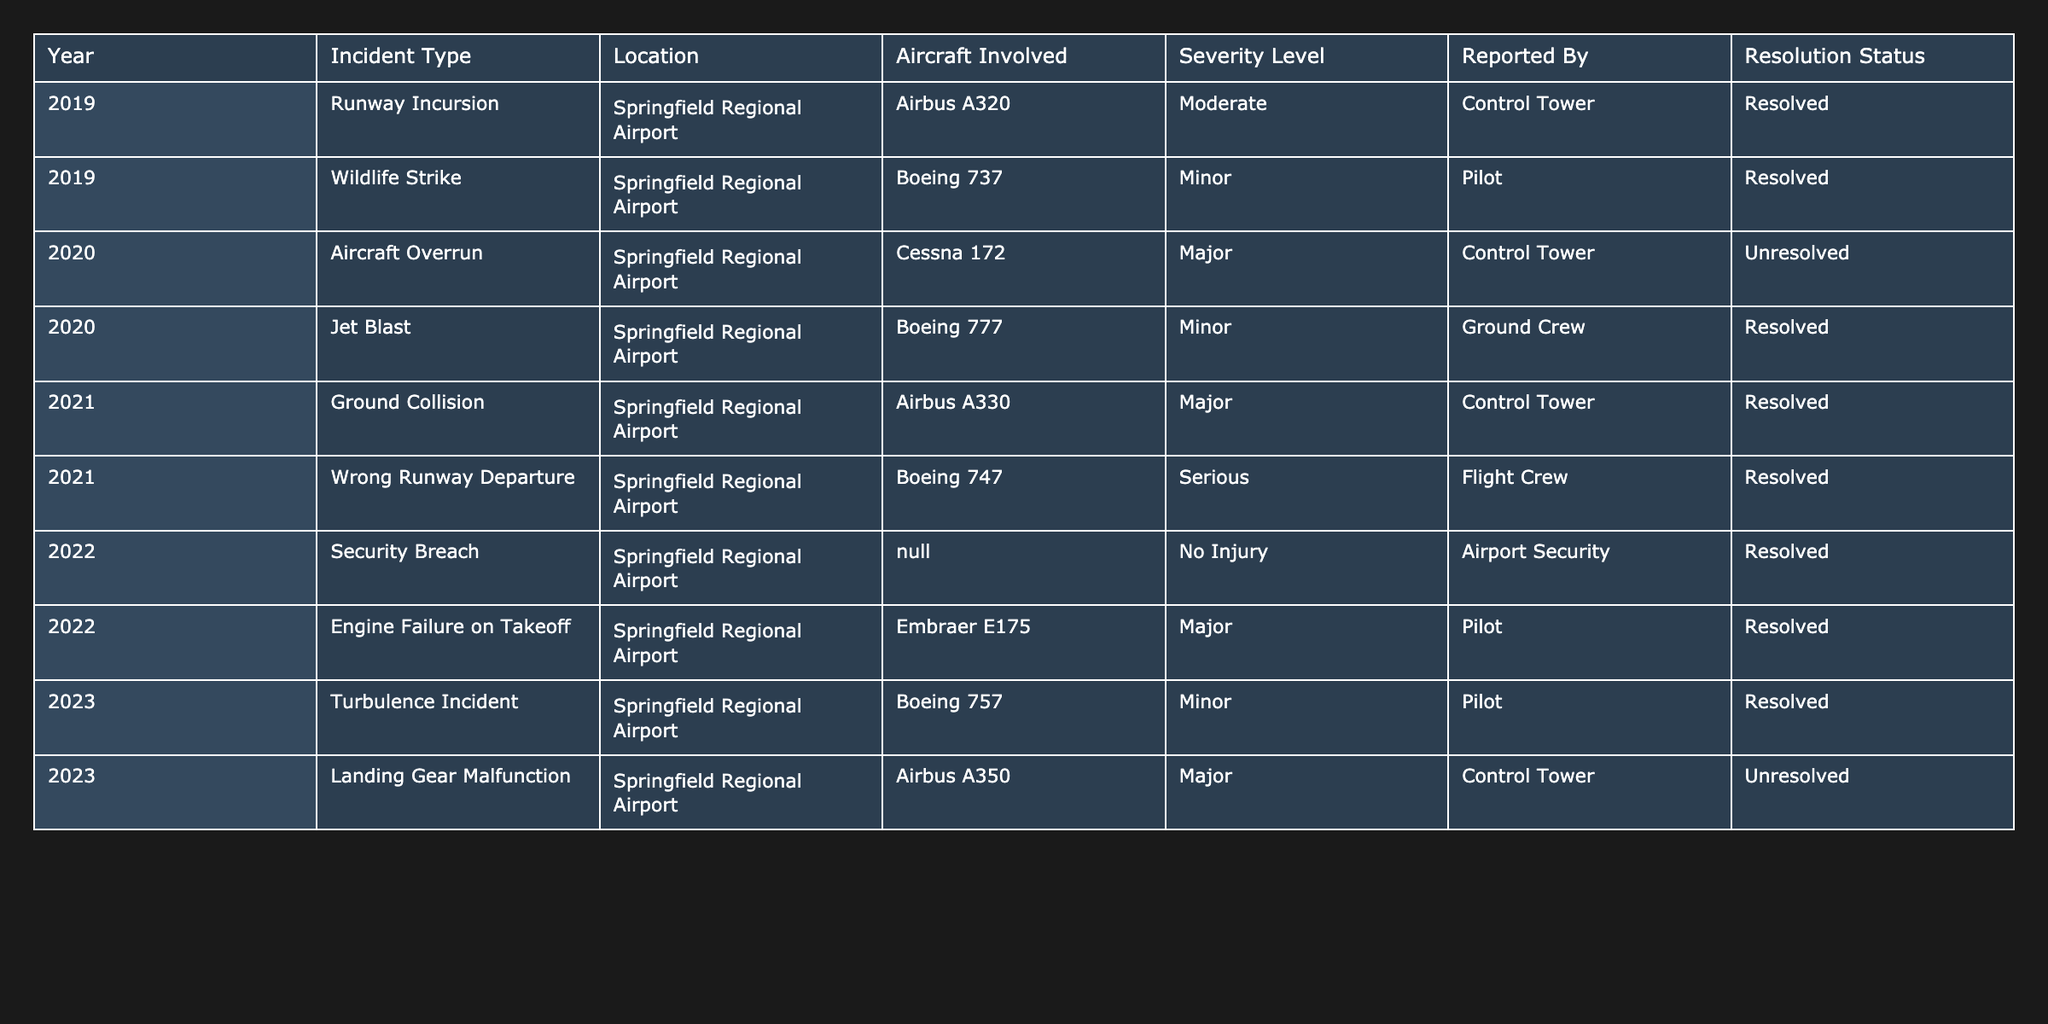What was the most common incident type reported in 2022? In 2022, there were two reported incidents: a security breach and an engine failure on takeoff. Since the security breach was marked as "No Injury" and the engine failure was classified as "Major", the security breach is established as the most holistic occurrence due to its completeness and non-injury nature.
Answer: Security Breach How many incidents were reported as unresolved? From the table, there are two incidents marked as unresolved: one in 2020 (Aircraft Overrun) and one in 2023 (Landing Gear Malfunction). By counting these occurrences, we arrive at the total of two unresolved incidents.
Answer: 2 Which year had the highest severity level incidents, and what were they? Upon reviewing the severity levels across the years, both 2020 and 2021 had Major incidents, specifically Aircraft Overrun and Ground Collision, respectively. However, 2021 also had a Serious incident (Wrong Runway Departure). Hence, 2021 had the highest severity level incidents overall.
Answer: 2021; Ground Collision, Wrong Runway Departure Were there any incidents reported without an aircraft involved? The 2022 security breach incident is classified as N/A for Aircraft Involved, confirming the occurrence without any aircraft in that specific case. Therefore, there is indeed an incident reported without an aircraft involved.
Answer: Yes What was the total number of incidents reported from 2019 to 2023? By counting the rows in the data, we find there are ten incidents in total reported from 2019 to 2023, showing a comprehensive collection of safety-related occurrences in those years, thus confirming the total.
Answer: 10 In which year did the only unresolved incident occur? Reviewing the resolution status for each year, the unresolved incident is specifically listed in 2023 with the Landing Gear Malfunction categorized as unresolved. Therefore, the only unresolved incident occurred in 2023.
Answer: 2023 Which incident type had the most severe classification across all years? The incidents can be categorized into severity levels: Minor, Moderate, Major, and Serious. Among these, "Serious" is the highest classification. Since the Wrong Runway Departure in 2021 falls under this classification, it represents the most severe incident type reported across all years.
Answer: Wrong Runway Departure How many incidents were reported by the Control Tower? The incidents reported by the Control Tower include both the Aircraft Overrun (2020), Ground Collision (2021), and Landing Gear Malfunction (2023), totalizing to three incidents. Thus, the count comprises all occurrences initiated by the Control Tower specifics.
Answer: 3 What percentage of incidents in 2020 were resolved? In 2020, there were two incidents, one resolved (Jet Blast) and one unresolved (Aircraft Overrun). Therefore, to calculate the percentage of resolved incidents: (1 resolved/2 total) * 100 = 50%. Thus, half of the incidents reported in 2020 were resolved.
Answer: 50% 